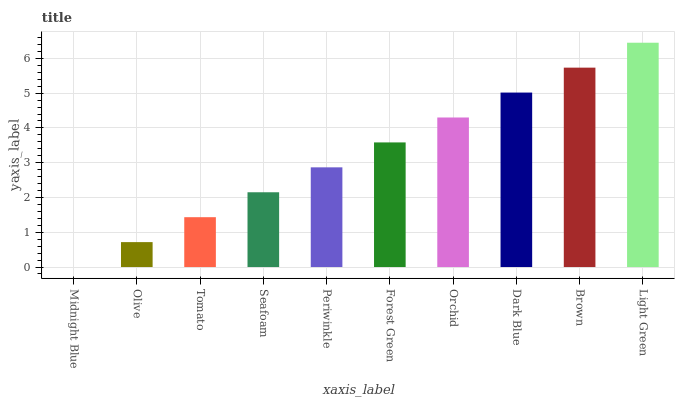Is Olive the minimum?
Answer yes or no. No. Is Olive the maximum?
Answer yes or no. No. Is Olive greater than Midnight Blue?
Answer yes or no. Yes. Is Midnight Blue less than Olive?
Answer yes or no. Yes. Is Midnight Blue greater than Olive?
Answer yes or no. No. Is Olive less than Midnight Blue?
Answer yes or no. No. Is Forest Green the high median?
Answer yes or no. Yes. Is Periwinkle the low median?
Answer yes or no. Yes. Is Brown the high median?
Answer yes or no. No. Is Orchid the low median?
Answer yes or no. No. 